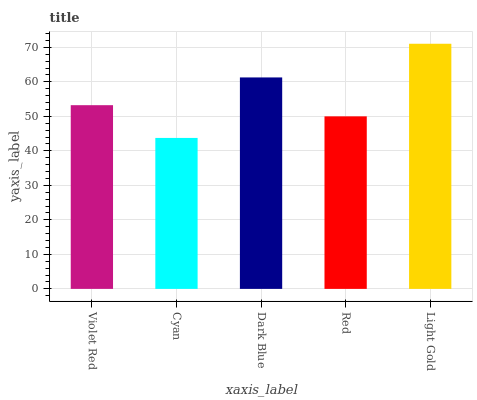Is Cyan the minimum?
Answer yes or no. Yes. Is Light Gold the maximum?
Answer yes or no. Yes. Is Dark Blue the minimum?
Answer yes or no. No. Is Dark Blue the maximum?
Answer yes or no. No. Is Dark Blue greater than Cyan?
Answer yes or no. Yes. Is Cyan less than Dark Blue?
Answer yes or no. Yes. Is Cyan greater than Dark Blue?
Answer yes or no. No. Is Dark Blue less than Cyan?
Answer yes or no. No. Is Violet Red the high median?
Answer yes or no. Yes. Is Violet Red the low median?
Answer yes or no. Yes. Is Dark Blue the high median?
Answer yes or no. No. Is Dark Blue the low median?
Answer yes or no. No. 